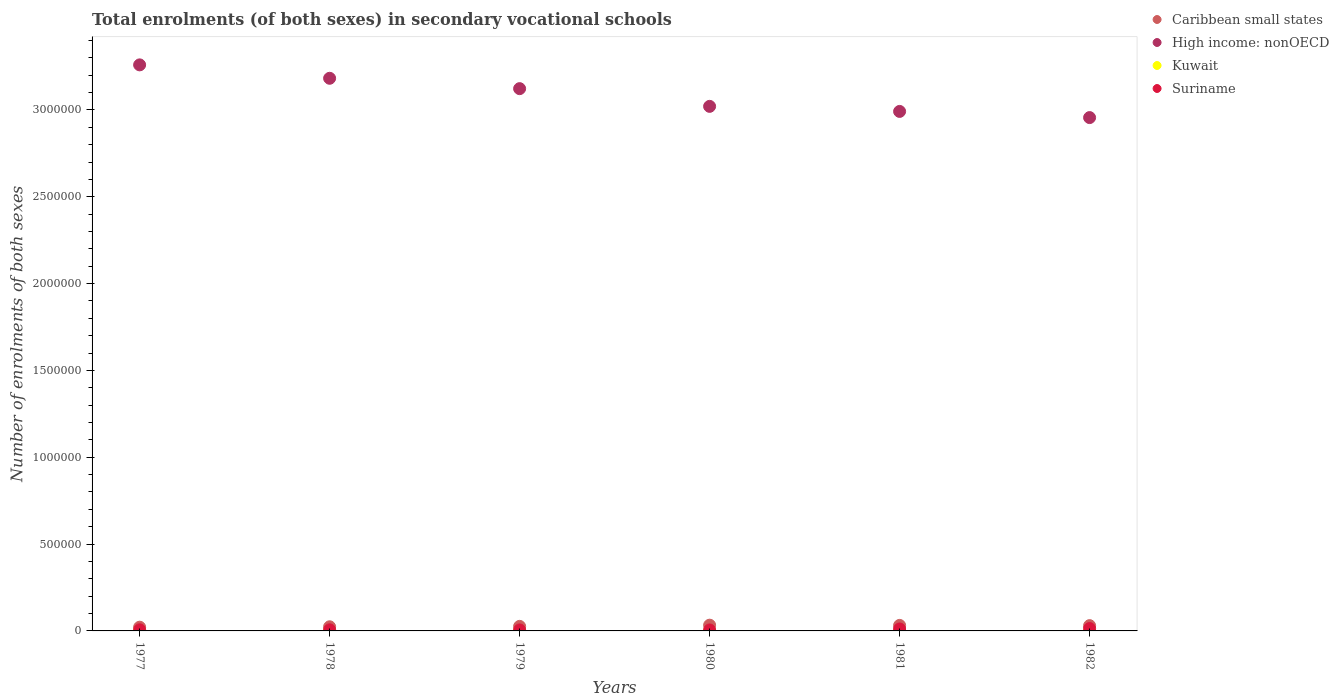How many different coloured dotlines are there?
Your answer should be compact. 4. What is the number of enrolments in secondary schools in Suriname in 1982?
Make the answer very short. 1.37e+04. Across all years, what is the maximum number of enrolments in secondary schools in High income: nonOECD?
Provide a short and direct response. 3.26e+06. Across all years, what is the minimum number of enrolments in secondary schools in Caribbean small states?
Your answer should be very brief. 2.14e+04. In which year was the number of enrolments in secondary schools in Kuwait minimum?
Provide a succinct answer. 1980. What is the total number of enrolments in secondary schools in Suriname in the graph?
Your answer should be compact. 4.91e+04. What is the difference between the number of enrolments in secondary schools in High income: nonOECD in 1979 and that in 1981?
Your answer should be compact. 1.31e+05. What is the difference between the number of enrolments in secondary schools in Kuwait in 1981 and the number of enrolments in secondary schools in Suriname in 1982?
Give a very brief answer. -1.33e+04. What is the average number of enrolments in secondary schools in Suriname per year?
Offer a very short reply. 8178. In the year 1978, what is the difference between the number of enrolments in secondary schools in Caribbean small states and number of enrolments in secondary schools in Kuwait?
Offer a terse response. 2.29e+04. In how many years, is the number of enrolments in secondary schools in Kuwait greater than 3300000?
Ensure brevity in your answer.  0. What is the ratio of the number of enrolments in secondary schools in Caribbean small states in 1980 to that in 1981?
Provide a succinct answer. 1.04. What is the difference between the highest and the second highest number of enrolments in secondary schools in High income: nonOECD?
Provide a succinct answer. 7.72e+04. What is the difference between the highest and the lowest number of enrolments in secondary schools in Suriname?
Make the answer very short. 8151. In how many years, is the number of enrolments in secondary schools in High income: nonOECD greater than the average number of enrolments in secondary schools in High income: nonOECD taken over all years?
Ensure brevity in your answer.  3. Is it the case that in every year, the sum of the number of enrolments in secondary schools in Suriname and number of enrolments in secondary schools in Kuwait  is greater than the sum of number of enrolments in secondary schools in High income: nonOECD and number of enrolments in secondary schools in Caribbean small states?
Give a very brief answer. Yes. Is it the case that in every year, the sum of the number of enrolments in secondary schools in Kuwait and number of enrolments in secondary schools in Caribbean small states  is greater than the number of enrolments in secondary schools in High income: nonOECD?
Offer a terse response. No. Is the number of enrolments in secondary schools in Caribbean small states strictly greater than the number of enrolments in secondary schools in Kuwait over the years?
Your response must be concise. Yes. How many years are there in the graph?
Make the answer very short. 6. What is the difference between two consecutive major ticks on the Y-axis?
Provide a succinct answer. 5.00e+05. Are the values on the major ticks of Y-axis written in scientific E-notation?
Offer a terse response. No. Does the graph contain grids?
Your answer should be compact. No. What is the title of the graph?
Your answer should be very brief. Total enrolments (of both sexes) in secondary vocational schools. What is the label or title of the Y-axis?
Make the answer very short. Number of enrolments of both sexes. What is the Number of enrolments of both sexes in Caribbean small states in 1977?
Offer a terse response. 2.14e+04. What is the Number of enrolments of both sexes of High income: nonOECD in 1977?
Your response must be concise. 3.26e+06. What is the Number of enrolments of both sexes of Kuwait in 1977?
Make the answer very short. 1184. What is the Number of enrolments of both sexes in Suriname in 1977?
Keep it short and to the point. 6375. What is the Number of enrolments of both sexes of Caribbean small states in 1978?
Make the answer very short. 2.38e+04. What is the Number of enrolments of both sexes in High income: nonOECD in 1978?
Your answer should be compact. 3.18e+06. What is the Number of enrolments of both sexes of Kuwait in 1978?
Offer a very short reply. 871. What is the Number of enrolments of both sexes in Suriname in 1978?
Offer a very short reply. 6346. What is the Number of enrolments of both sexes of Caribbean small states in 1979?
Ensure brevity in your answer.  2.62e+04. What is the Number of enrolments of both sexes of High income: nonOECD in 1979?
Your response must be concise. 3.12e+06. What is the Number of enrolments of both sexes in Kuwait in 1979?
Ensure brevity in your answer.  705. What is the Number of enrolments of both sexes of Suriname in 1979?
Give a very brief answer. 5736. What is the Number of enrolments of both sexes of Caribbean small states in 1980?
Keep it short and to the point. 3.31e+04. What is the Number of enrolments of both sexes in High income: nonOECD in 1980?
Your answer should be compact. 3.02e+06. What is the Number of enrolments of both sexes of Kuwait in 1980?
Provide a succinct answer. 403. What is the Number of enrolments of both sexes in Suriname in 1980?
Provide a succinct answer. 5590. What is the Number of enrolments of both sexes in Caribbean small states in 1981?
Offer a terse response. 3.18e+04. What is the Number of enrolments of both sexes in High income: nonOECD in 1981?
Ensure brevity in your answer.  2.99e+06. What is the Number of enrolments of both sexes of Kuwait in 1981?
Give a very brief answer. 421. What is the Number of enrolments of both sexes of Suriname in 1981?
Your answer should be very brief. 1.13e+04. What is the Number of enrolments of both sexes in Caribbean small states in 1982?
Your answer should be compact. 3.04e+04. What is the Number of enrolments of both sexes of High income: nonOECD in 1982?
Provide a succinct answer. 2.96e+06. What is the Number of enrolments of both sexes in Kuwait in 1982?
Offer a very short reply. 672. What is the Number of enrolments of both sexes of Suriname in 1982?
Ensure brevity in your answer.  1.37e+04. Across all years, what is the maximum Number of enrolments of both sexes in Caribbean small states?
Keep it short and to the point. 3.31e+04. Across all years, what is the maximum Number of enrolments of both sexes in High income: nonOECD?
Your answer should be very brief. 3.26e+06. Across all years, what is the maximum Number of enrolments of both sexes of Kuwait?
Make the answer very short. 1184. Across all years, what is the maximum Number of enrolments of both sexes of Suriname?
Offer a very short reply. 1.37e+04. Across all years, what is the minimum Number of enrolments of both sexes of Caribbean small states?
Provide a succinct answer. 2.14e+04. Across all years, what is the minimum Number of enrolments of both sexes of High income: nonOECD?
Ensure brevity in your answer.  2.96e+06. Across all years, what is the minimum Number of enrolments of both sexes of Kuwait?
Ensure brevity in your answer.  403. Across all years, what is the minimum Number of enrolments of both sexes of Suriname?
Provide a short and direct response. 5590. What is the total Number of enrolments of both sexes in Caribbean small states in the graph?
Your response must be concise. 1.67e+05. What is the total Number of enrolments of both sexes of High income: nonOECD in the graph?
Keep it short and to the point. 1.85e+07. What is the total Number of enrolments of both sexes of Kuwait in the graph?
Keep it short and to the point. 4256. What is the total Number of enrolments of both sexes in Suriname in the graph?
Your answer should be compact. 4.91e+04. What is the difference between the Number of enrolments of both sexes in Caribbean small states in 1977 and that in 1978?
Make the answer very short. -2360.25. What is the difference between the Number of enrolments of both sexes of High income: nonOECD in 1977 and that in 1978?
Your answer should be compact. 7.72e+04. What is the difference between the Number of enrolments of both sexes in Kuwait in 1977 and that in 1978?
Your response must be concise. 313. What is the difference between the Number of enrolments of both sexes of Caribbean small states in 1977 and that in 1979?
Provide a short and direct response. -4742. What is the difference between the Number of enrolments of both sexes in High income: nonOECD in 1977 and that in 1979?
Your answer should be very brief. 1.37e+05. What is the difference between the Number of enrolments of both sexes in Kuwait in 1977 and that in 1979?
Keep it short and to the point. 479. What is the difference between the Number of enrolments of both sexes in Suriname in 1977 and that in 1979?
Offer a very short reply. 639. What is the difference between the Number of enrolments of both sexes in Caribbean small states in 1977 and that in 1980?
Provide a short and direct response. -1.17e+04. What is the difference between the Number of enrolments of both sexes in High income: nonOECD in 1977 and that in 1980?
Your response must be concise. 2.39e+05. What is the difference between the Number of enrolments of both sexes in Kuwait in 1977 and that in 1980?
Offer a terse response. 781. What is the difference between the Number of enrolments of both sexes in Suriname in 1977 and that in 1980?
Keep it short and to the point. 785. What is the difference between the Number of enrolments of both sexes in Caribbean small states in 1977 and that in 1981?
Ensure brevity in your answer.  -1.03e+04. What is the difference between the Number of enrolments of both sexes in High income: nonOECD in 1977 and that in 1981?
Your answer should be compact. 2.68e+05. What is the difference between the Number of enrolments of both sexes in Kuwait in 1977 and that in 1981?
Give a very brief answer. 763. What is the difference between the Number of enrolments of both sexes in Suriname in 1977 and that in 1981?
Offer a terse response. -4905. What is the difference between the Number of enrolments of both sexes of Caribbean small states in 1977 and that in 1982?
Offer a terse response. -8942.43. What is the difference between the Number of enrolments of both sexes in High income: nonOECD in 1977 and that in 1982?
Offer a very short reply. 3.04e+05. What is the difference between the Number of enrolments of both sexes of Kuwait in 1977 and that in 1982?
Your response must be concise. 512. What is the difference between the Number of enrolments of both sexes in Suriname in 1977 and that in 1982?
Your answer should be very brief. -7366. What is the difference between the Number of enrolments of both sexes in Caribbean small states in 1978 and that in 1979?
Provide a succinct answer. -2381.75. What is the difference between the Number of enrolments of both sexes of High income: nonOECD in 1978 and that in 1979?
Offer a very short reply. 5.97e+04. What is the difference between the Number of enrolments of both sexes of Kuwait in 1978 and that in 1979?
Offer a terse response. 166. What is the difference between the Number of enrolments of both sexes in Suriname in 1978 and that in 1979?
Your response must be concise. 610. What is the difference between the Number of enrolments of both sexes of Caribbean small states in 1978 and that in 1980?
Keep it short and to the point. -9299.25. What is the difference between the Number of enrolments of both sexes of High income: nonOECD in 1978 and that in 1980?
Offer a terse response. 1.62e+05. What is the difference between the Number of enrolments of both sexes in Kuwait in 1978 and that in 1980?
Offer a terse response. 468. What is the difference between the Number of enrolments of both sexes in Suriname in 1978 and that in 1980?
Your response must be concise. 756. What is the difference between the Number of enrolments of both sexes in Caribbean small states in 1978 and that in 1981?
Offer a terse response. -7966.27. What is the difference between the Number of enrolments of both sexes of High income: nonOECD in 1978 and that in 1981?
Make the answer very short. 1.91e+05. What is the difference between the Number of enrolments of both sexes in Kuwait in 1978 and that in 1981?
Provide a short and direct response. 450. What is the difference between the Number of enrolments of both sexes in Suriname in 1978 and that in 1981?
Make the answer very short. -4934. What is the difference between the Number of enrolments of both sexes in Caribbean small states in 1978 and that in 1982?
Your answer should be very brief. -6582.18. What is the difference between the Number of enrolments of both sexes of High income: nonOECD in 1978 and that in 1982?
Offer a very short reply. 2.26e+05. What is the difference between the Number of enrolments of both sexes of Kuwait in 1978 and that in 1982?
Provide a succinct answer. 199. What is the difference between the Number of enrolments of both sexes in Suriname in 1978 and that in 1982?
Keep it short and to the point. -7395. What is the difference between the Number of enrolments of both sexes of Caribbean small states in 1979 and that in 1980?
Your response must be concise. -6917.51. What is the difference between the Number of enrolments of both sexes of High income: nonOECD in 1979 and that in 1980?
Your answer should be compact. 1.02e+05. What is the difference between the Number of enrolments of both sexes in Kuwait in 1979 and that in 1980?
Offer a terse response. 302. What is the difference between the Number of enrolments of both sexes of Suriname in 1979 and that in 1980?
Provide a short and direct response. 146. What is the difference between the Number of enrolments of both sexes of Caribbean small states in 1979 and that in 1981?
Provide a succinct answer. -5584.52. What is the difference between the Number of enrolments of both sexes in High income: nonOECD in 1979 and that in 1981?
Make the answer very short. 1.31e+05. What is the difference between the Number of enrolments of both sexes in Kuwait in 1979 and that in 1981?
Give a very brief answer. 284. What is the difference between the Number of enrolments of both sexes in Suriname in 1979 and that in 1981?
Ensure brevity in your answer.  -5544. What is the difference between the Number of enrolments of both sexes of Caribbean small states in 1979 and that in 1982?
Your answer should be compact. -4200.43. What is the difference between the Number of enrolments of both sexes of High income: nonOECD in 1979 and that in 1982?
Keep it short and to the point. 1.67e+05. What is the difference between the Number of enrolments of both sexes of Suriname in 1979 and that in 1982?
Offer a terse response. -8005. What is the difference between the Number of enrolments of both sexes of Caribbean small states in 1980 and that in 1981?
Your answer should be very brief. 1332.99. What is the difference between the Number of enrolments of both sexes in High income: nonOECD in 1980 and that in 1981?
Provide a succinct answer. 2.91e+04. What is the difference between the Number of enrolments of both sexes in Kuwait in 1980 and that in 1981?
Your response must be concise. -18. What is the difference between the Number of enrolments of both sexes of Suriname in 1980 and that in 1981?
Provide a succinct answer. -5690. What is the difference between the Number of enrolments of both sexes of Caribbean small states in 1980 and that in 1982?
Keep it short and to the point. 2717.08. What is the difference between the Number of enrolments of both sexes of High income: nonOECD in 1980 and that in 1982?
Provide a short and direct response. 6.47e+04. What is the difference between the Number of enrolments of both sexes in Kuwait in 1980 and that in 1982?
Ensure brevity in your answer.  -269. What is the difference between the Number of enrolments of both sexes of Suriname in 1980 and that in 1982?
Ensure brevity in your answer.  -8151. What is the difference between the Number of enrolments of both sexes of Caribbean small states in 1981 and that in 1982?
Your answer should be very brief. 1384.09. What is the difference between the Number of enrolments of both sexes in High income: nonOECD in 1981 and that in 1982?
Offer a terse response. 3.55e+04. What is the difference between the Number of enrolments of both sexes of Kuwait in 1981 and that in 1982?
Ensure brevity in your answer.  -251. What is the difference between the Number of enrolments of both sexes in Suriname in 1981 and that in 1982?
Make the answer very short. -2461. What is the difference between the Number of enrolments of both sexes of Caribbean small states in 1977 and the Number of enrolments of both sexes of High income: nonOECD in 1978?
Your response must be concise. -3.16e+06. What is the difference between the Number of enrolments of both sexes of Caribbean small states in 1977 and the Number of enrolments of both sexes of Kuwait in 1978?
Ensure brevity in your answer.  2.06e+04. What is the difference between the Number of enrolments of both sexes in Caribbean small states in 1977 and the Number of enrolments of both sexes in Suriname in 1978?
Keep it short and to the point. 1.51e+04. What is the difference between the Number of enrolments of both sexes of High income: nonOECD in 1977 and the Number of enrolments of both sexes of Kuwait in 1978?
Keep it short and to the point. 3.26e+06. What is the difference between the Number of enrolments of both sexes of High income: nonOECD in 1977 and the Number of enrolments of both sexes of Suriname in 1978?
Offer a terse response. 3.25e+06. What is the difference between the Number of enrolments of both sexes in Kuwait in 1977 and the Number of enrolments of both sexes in Suriname in 1978?
Offer a very short reply. -5162. What is the difference between the Number of enrolments of both sexes in Caribbean small states in 1977 and the Number of enrolments of both sexes in High income: nonOECD in 1979?
Your response must be concise. -3.10e+06. What is the difference between the Number of enrolments of both sexes in Caribbean small states in 1977 and the Number of enrolments of both sexes in Kuwait in 1979?
Provide a short and direct response. 2.07e+04. What is the difference between the Number of enrolments of both sexes in Caribbean small states in 1977 and the Number of enrolments of both sexes in Suriname in 1979?
Your answer should be compact. 1.57e+04. What is the difference between the Number of enrolments of both sexes in High income: nonOECD in 1977 and the Number of enrolments of both sexes in Kuwait in 1979?
Your answer should be very brief. 3.26e+06. What is the difference between the Number of enrolments of both sexes in High income: nonOECD in 1977 and the Number of enrolments of both sexes in Suriname in 1979?
Your answer should be very brief. 3.25e+06. What is the difference between the Number of enrolments of both sexes of Kuwait in 1977 and the Number of enrolments of both sexes of Suriname in 1979?
Offer a very short reply. -4552. What is the difference between the Number of enrolments of both sexes in Caribbean small states in 1977 and the Number of enrolments of both sexes in High income: nonOECD in 1980?
Your answer should be very brief. -3.00e+06. What is the difference between the Number of enrolments of both sexes of Caribbean small states in 1977 and the Number of enrolments of both sexes of Kuwait in 1980?
Give a very brief answer. 2.10e+04. What is the difference between the Number of enrolments of both sexes in Caribbean small states in 1977 and the Number of enrolments of both sexes in Suriname in 1980?
Your answer should be compact. 1.59e+04. What is the difference between the Number of enrolments of both sexes of High income: nonOECD in 1977 and the Number of enrolments of both sexes of Kuwait in 1980?
Ensure brevity in your answer.  3.26e+06. What is the difference between the Number of enrolments of both sexes in High income: nonOECD in 1977 and the Number of enrolments of both sexes in Suriname in 1980?
Offer a terse response. 3.25e+06. What is the difference between the Number of enrolments of both sexes in Kuwait in 1977 and the Number of enrolments of both sexes in Suriname in 1980?
Your answer should be compact. -4406. What is the difference between the Number of enrolments of both sexes in Caribbean small states in 1977 and the Number of enrolments of both sexes in High income: nonOECD in 1981?
Offer a very short reply. -2.97e+06. What is the difference between the Number of enrolments of both sexes of Caribbean small states in 1977 and the Number of enrolments of both sexes of Kuwait in 1981?
Offer a very short reply. 2.10e+04. What is the difference between the Number of enrolments of both sexes in Caribbean small states in 1977 and the Number of enrolments of both sexes in Suriname in 1981?
Make the answer very short. 1.02e+04. What is the difference between the Number of enrolments of both sexes of High income: nonOECD in 1977 and the Number of enrolments of both sexes of Kuwait in 1981?
Offer a very short reply. 3.26e+06. What is the difference between the Number of enrolments of both sexes in High income: nonOECD in 1977 and the Number of enrolments of both sexes in Suriname in 1981?
Give a very brief answer. 3.25e+06. What is the difference between the Number of enrolments of both sexes of Kuwait in 1977 and the Number of enrolments of both sexes of Suriname in 1981?
Make the answer very short. -1.01e+04. What is the difference between the Number of enrolments of both sexes in Caribbean small states in 1977 and the Number of enrolments of both sexes in High income: nonOECD in 1982?
Give a very brief answer. -2.93e+06. What is the difference between the Number of enrolments of both sexes in Caribbean small states in 1977 and the Number of enrolments of both sexes in Kuwait in 1982?
Offer a very short reply. 2.08e+04. What is the difference between the Number of enrolments of both sexes of Caribbean small states in 1977 and the Number of enrolments of both sexes of Suriname in 1982?
Keep it short and to the point. 7703.19. What is the difference between the Number of enrolments of both sexes in High income: nonOECD in 1977 and the Number of enrolments of both sexes in Kuwait in 1982?
Give a very brief answer. 3.26e+06. What is the difference between the Number of enrolments of both sexes in High income: nonOECD in 1977 and the Number of enrolments of both sexes in Suriname in 1982?
Ensure brevity in your answer.  3.25e+06. What is the difference between the Number of enrolments of both sexes in Kuwait in 1977 and the Number of enrolments of both sexes in Suriname in 1982?
Offer a terse response. -1.26e+04. What is the difference between the Number of enrolments of both sexes of Caribbean small states in 1978 and the Number of enrolments of both sexes of High income: nonOECD in 1979?
Give a very brief answer. -3.10e+06. What is the difference between the Number of enrolments of both sexes of Caribbean small states in 1978 and the Number of enrolments of both sexes of Kuwait in 1979?
Offer a terse response. 2.31e+04. What is the difference between the Number of enrolments of both sexes of Caribbean small states in 1978 and the Number of enrolments of both sexes of Suriname in 1979?
Keep it short and to the point. 1.81e+04. What is the difference between the Number of enrolments of both sexes of High income: nonOECD in 1978 and the Number of enrolments of both sexes of Kuwait in 1979?
Offer a very short reply. 3.18e+06. What is the difference between the Number of enrolments of both sexes in High income: nonOECD in 1978 and the Number of enrolments of both sexes in Suriname in 1979?
Give a very brief answer. 3.18e+06. What is the difference between the Number of enrolments of both sexes of Kuwait in 1978 and the Number of enrolments of both sexes of Suriname in 1979?
Keep it short and to the point. -4865. What is the difference between the Number of enrolments of both sexes of Caribbean small states in 1978 and the Number of enrolments of both sexes of High income: nonOECD in 1980?
Give a very brief answer. -3.00e+06. What is the difference between the Number of enrolments of both sexes in Caribbean small states in 1978 and the Number of enrolments of both sexes in Kuwait in 1980?
Make the answer very short. 2.34e+04. What is the difference between the Number of enrolments of both sexes in Caribbean small states in 1978 and the Number of enrolments of both sexes in Suriname in 1980?
Make the answer very short. 1.82e+04. What is the difference between the Number of enrolments of both sexes in High income: nonOECD in 1978 and the Number of enrolments of both sexes in Kuwait in 1980?
Provide a succinct answer. 3.18e+06. What is the difference between the Number of enrolments of both sexes of High income: nonOECD in 1978 and the Number of enrolments of both sexes of Suriname in 1980?
Make the answer very short. 3.18e+06. What is the difference between the Number of enrolments of both sexes in Kuwait in 1978 and the Number of enrolments of both sexes in Suriname in 1980?
Offer a terse response. -4719. What is the difference between the Number of enrolments of both sexes in Caribbean small states in 1978 and the Number of enrolments of both sexes in High income: nonOECD in 1981?
Keep it short and to the point. -2.97e+06. What is the difference between the Number of enrolments of both sexes of Caribbean small states in 1978 and the Number of enrolments of both sexes of Kuwait in 1981?
Make the answer very short. 2.34e+04. What is the difference between the Number of enrolments of both sexes of Caribbean small states in 1978 and the Number of enrolments of both sexes of Suriname in 1981?
Make the answer very short. 1.25e+04. What is the difference between the Number of enrolments of both sexes in High income: nonOECD in 1978 and the Number of enrolments of both sexes in Kuwait in 1981?
Provide a short and direct response. 3.18e+06. What is the difference between the Number of enrolments of both sexes in High income: nonOECD in 1978 and the Number of enrolments of both sexes in Suriname in 1981?
Offer a very short reply. 3.17e+06. What is the difference between the Number of enrolments of both sexes of Kuwait in 1978 and the Number of enrolments of both sexes of Suriname in 1981?
Make the answer very short. -1.04e+04. What is the difference between the Number of enrolments of both sexes in Caribbean small states in 1978 and the Number of enrolments of both sexes in High income: nonOECD in 1982?
Keep it short and to the point. -2.93e+06. What is the difference between the Number of enrolments of both sexes in Caribbean small states in 1978 and the Number of enrolments of both sexes in Kuwait in 1982?
Your response must be concise. 2.31e+04. What is the difference between the Number of enrolments of both sexes of Caribbean small states in 1978 and the Number of enrolments of both sexes of Suriname in 1982?
Your answer should be very brief. 1.01e+04. What is the difference between the Number of enrolments of both sexes of High income: nonOECD in 1978 and the Number of enrolments of both sexes of Kuwait in 1982?
Your answer should be compact. 3.18e+06. What is the difference between the Number of enrolments of both sexes of High income: nonOECD in 1978 and the Number of enrolments of both sexes of Suriname in 1982?
Your response must be concise. 3.17e+06. What is the difference between the Number of enrolments of both sexes of Kuwait in 1978 and the Number of enrolments of both sexes of Suriname in 1982?
Keep it short and to the point. -1.29e+04. What is the difference between the Number of enrolments of both sexes of Caribbean small states in 1979 and the Number of enrolments of both sexes of High income: nonOECD in 1980?
Your answer should be compact. -2.99e+06. What is the difference between the Number of enrolments of both sexes of Caribbean small states in 1979 and the Number of enrolments of both sexes of Kuwait in 1980?
Provide a succinct answer. 2.58e+04. What is the difference between the Number of enrolments of both sexes in Caribbean small states in 1979 and the Number of enrolments of both sexes in Suriname in 1980?
Provide a succinct answer. 2.06e+04. What is the difference between the Number of enrolments of both sexes of High income: nonOECD in 1979 and the Number of enrolments of both sexes of Kuwait in 1980?
Offer a very short reply. 3.12e+06. What is the difference between the Number of enrolments of both sexes in High income: nonOECD in 1979 and the Number of enrolments of both sexes in Suriname in 1980?
Offer a terse response. 3.12e+06. What is the difference between the Number of enrolments of both sexes of Kuwait in 1979 and the Number of enrolments of both sexes of Suriname in 1980?
Your answer should be compact. -4885. What is the difference between the Number of enrolments of both sexes of Caribbean small states in 1979 and the Number of enrolments of both sexes of High income: nonOECD in 1981?
Ensure brevity in your answer.  -2.97e+06. What is the difference between the Number of enrolments of both sexes of Caribbean small states in 1979 and the Number of enrolments of both sexes of Kuwait in 1981?
Give a very brief answer. 2.58e+04. What is the difference between the Number of enrolments of both sexes of Caribbean small states in 1979 and the Number of enrolments of both sexes of Suriname in 1981?
Make the answer very short. 1.49e+04. What is the difference between the Number of enrolments of both sexes in High income: nonOECD in 1979 and the Number of enrolments of both sexes in Kuwait in 1981?
Give a very brief answer. 3.12e+06. What is the difference between the Number of enrolments of both sexes in High income: nonOECD in 1979 and the Number of enrolments of both sexes in Suriname in 1981?
Your response must be concise. 3.11e+06. What is the difference between the Number of enrolments of both sexes in Kuwait in 1979 and the Number of enrolments of both sexes in Suriname in 1981?
Ensure brevity in your answer.  -1.06e+04. What is the difference between the Number of enrolments of both sexes in Caribbean small states in 1979 and the Number of enrolments of both sexes in High income: nonOECD in 1982?
Your response must be concise. -2.93e+06. What is the difference between the Number of enrolments of both sexes in Caribbean small states in 1979 and the Number of enrolments of both sexes in Kuwait in 1982?
Offer a terse response. 2.55e+04. What is the difference between the Number of enrolments of both sexes of Caribbean small states in 1979 and the Number of enrolments of both sexes of Suriname in 1982?
Offer a very short reply. 1.24e+04. What is the difference between the Number of enrolments of both sexes in High income: nonOECD in 1979 and the Number of enrolments of both sexes in Kuwait in 1982?
Keep it short and to the point. 3.12e+06. What is the difference between the Number of enrolments of both sexes of High income: nonOECD in 1979 and the Number of enrolments of both sexes of Suriname in 1982?
Offer a very short reply. 3.11e+06. What is the difference between the Number of enrolments of both sexes of Kuwait in 1979 and the Number of enrolments of both sexes of Suriname in 1982?
Offer a terse response. -1.30e+04. What is the difference between the Number of enrolments of both sexes in Caribbean small states in 1980 and the Number of enrolments of both sexes in High income: nonOECD in 1981?
Provide a short and direct response. -2.96e+06. What is the difference between the Number of enrolments of both sexes in Caribbean small states in 1980 and the Number of enrolments of both sexes in Kuwait in 1981?
Give a very brief answer. 3.27e+04. What is the difference between the Number of enrolments of both sexes of Caribbean small states in 1980 and the Number of enrolments of both sexes of Suriname in 1981?
Provide a short and direct response. 2.18e+04. What is the difference between the Number of enrolments of both sexes of High income: nonOECD in 1980 and the Number of enrolments of both sexes of Kuwait in 1981?
Your response must be concise. 3.02e+06. What is the difference between the Number of enrolments of both sexes in High income: nonOECD in 1980 and the Number of enrolments of both sexes in Suriname in 1981?
Your answer should be compact. 3.01e+06. What is the difference between the Number of enrolments of both sexes of Kuwait in 1980 and the Number of enrolments of both sexes of Suriname in 1981?
Provide a succinct answer. -1.09e+04. What is the difference between the Number of enrolments of both sexes in Caribbean small states in 1980 and the Number of enrolments of both sexes in High income: nonOECD in 1982?
Offer a terse response. -2.92e+06. What is the difference between the Number of enrolments of both sexes in Caribbean small states in 1980 and the Number of enrolments of both sexes in Kuwait in 1982?
Your answer should be compact. 3.24e+04. What is the difference between the Number of enrolments of both sexes in Caribbean small states in 1980 and the Number of enrolments of both sexes in Suriname in 1982?
Provide a short and direct response. 1.94e+04. What is the difference between the Number of enrolments of both sexes in High income: nonOECD in 1980 and the Number of enrolments of both sexes in Kuwait in 1982?
Your response must be concise. 3.02e+06. What is the difference between the Number of enrolments of both sexes in High income: nonOECD in 1980 and the Number of enrolments of both sexes in Suriname in 1982?
Give a very brief answer. 3.01e+06. What is the difference between the Number of enrolments of both sexes in Kuwait in 1980 and the Number of enrolments of both sexes in Suriname in 1982?
Keep it short and to the point. -1.33e+04. What is the difference between the Number of enrolments of both sexes in Caribbean small states in 1981 and the Number of enrolments of both sexes in High income: nonOECD in 1982?
Your answer should be compact. -2.92e+06. What is the difference between the Number of enrolments of both sexes of Caribbean small states in 1981 and the Number of enrolments of both sexes of Kuwait in 1982?
Your answer should be compact. 3.11e+04. What is the difference between the Number of enrolments of both sexes in Caribbean small states in 1981 and the Number of enrolments of both sexes in Suriname in 1982?
Give a very brief answer. 1.80e+04. What is the difference between the Number of enrolments of both sexes of High income: nonOECD in 1981 and the Number of enrolments of both sexes of Kuwait in 1982?
Offer a terse response. 2.99e+06. What is the difference between the Number of enrolments of both sexes of High income: nonOECD in 1981 and the Number of enrolments of both sexes of Suriname in 1982?
Provide a succinct answer. 2.98e+06. What is the difference between the Number of enrolments of both sexes in Kuwait in 1981 and the Number of enrolments of both sexes in Suriname in 1982?
Your answer should be compact. -1.33e+04. What is the average Number of enrolments of both sexes in Caribbean small states per year?
Make the answer very short. 2.78e+04. What is the average Number of enrolments of both sexes in High income: nonOECD per year?
Your answer should be very brief. 3.09e+06. What is the average Number of enrolments of both sexes of Kuwait per year?
Make the answer very short. 709.33. What is the average Number of enrolments of both sexes in Suriname per year?
Provide a succinct answer. 8178. In the year 1977, what is the difference between the Number of enrolments of both sexes of Caribbean small states and Number of enrolments of both sexes of High income: nonOECD?
Your answer should be compact. -3.24e+06. In the year 1977, what is the difference between the Number of enrolments of both sexes of Caribbean small states and Number of enrolments of both sexes of Kuwait?
Your answer should be compact. 2.03e+04. In the year 1977, what is the difference between the Number of enrolments of both sexes of Caribbean small states and Number of enrolments of both sexes of Suriname?
Your answer should be very brief. 1.51e+04. In the year 1977, what is the difference between the Number of enrolments of both sexes of High income: nonOECD and Number of enrolments of both sexes of Kuwait?
Offer a very short reply. 3.26e+06. In the year 1977, what is the difference between the Number of enrolments of both sexes in High income: nonOECD and Number of enrolments of both sexes in Suriname?
Make the answer very short. 3.25e+06. In the year 1977, what is the difference between the Number of enrolments of both sexes of Kuwait and Number of enrolments of both sexes of Suriname?
Your answer should be compact. -5191. In the year 1978, what is the difference between the Number of enrolments of both sexes in Caribbean small states and Number of enrolments of both sexes in High income: nonOECD?
Keep it short and to the point. -3.16e+06. In the year 1978, what is the difference between the Number of enrolments of both sexes of Caribbean small states and Number of enrolments of both sexes of Kuwait?
Provide a short and direct response. 2.29e+04. In the year 1978, what is the difference between the Number of enrolments of both sexes in Caribbean small states and Number of enrolments of both sexes in Suriname?
Offer a terse response. 1.75e+04. In the year 1978, what is the difference between the Number of enrolments of both sexes in High income: nonOECD and Number of enrolments of both sexes in Kuwait?
Ensure brevity in your answer.  3.18e+06. In the year 1978, what is the difference between the Number of enrolments of both sexes of High income: nonOECD and Number of enrolments of both sexes of Suriname?
Provide a succinct answer. 3.18e+06. In the year 1978, what is the difference between the Number of enrolments of both sexes in Kuwait and Number of enrolments of both sexes in Suriname?
Your response must be concise. -5475. In the year 1979, what is the difference between the Number of enrolments of both sexes in Caribbean small states and Number of enrolments of both sexes in High income: nonOECD?
Keep it short and to the point. -3.10e+06. In the year 1979, what is the difference between the Number of enrolments of both sexes in Caribbean small states and Number of enrolments of both sexes in Kuwait?
Keep it short and to the point. 2.55e+04. In the year 1979, what is the difference between the Number of enrolments of both sexes in Caribbean small states and Number of enrolments of both sexes in Suriname?
Keep it short and to the point. 2.05e+04. In the year 1979, what is the difference between the Number of enrolments of both sexes in High income: nonOECD and Number of enrolments of both sexes in Kuwait?
Your answer should be compact. 3.12e+06. In the year 1979, what is the difference between the Number of enrolments of both sexes in High income: nonOECD and Number of enrolments of both sexes in Suriname?
Your answer should be compact. 3.12e+06. In the year 1979, what is the difference between the Number of enrolments of both sexes of Kuwait and Number of enrolments of both sexes of Suriname?
Provide a succinct answer. -5031. In the year 1980, what is the difference between the Number of enrolments of both sexes of Caribbean small states and Number of enrolments of both sexes of High income: nonOECD?
Offer a terse response. -2.99e+06. In the year 1980, what is the difference between the Number of enrolments of both sexes in Caribbean small states and Number of enrolments of both sexes in Kuwait?
Your answer should be very brief. 3.27e+04. In the year 1980, what is the difference between the Number of enrolments of both sexes in Caribbean small states and Number of enrolments of both sexes in Suriname?
Offer a very short reply. 2.75e+04. In the year 1980, what is the difference between the Number of enrolments of both sexes in High income: nonOECD and Number of enrolments of both sexes in Kuwait?
Your response must be concise. 3.02e+06. In the year 1980, what is the difference between the Number of enrolments of both sexes of High income: nonOECD and Number of enrolments of both sexes of Suriname?
Ensure brevity in your answer.  3.02e+06. In the year 1980, what is the difference between the Number of enrolments of both sexes of Kuwait and Number of enrolments of both sexes of Suriname?
Your answer should be very brief. -5187. In the year 1981, what is the difference between the Number of enrolments of both sexes of Caribbean small states and Number of enrolments of both sexes of High income: nonOECD?
Keep it short and to the point. -2.96e+06. In the year 1981, what is the difference between the Number of enrolments of both sexes of Caribbean small states and Number of enrolments of both sexes of Kuwait?
Ensure brevity in your answer.  3.13e+04. In the year 1981, what is the difference between the Number of enrolments of both sexes of Caribbean small states and Number of enrolments of both sexes of Suriname?
Offer a terse response. 2.05e+04. In the year 1981, what is the difference between the Number of enrolments of both sexes of High income: nonOECD and Number of enrolments of both sexes of Kuwait?
Ensure brevity in your answer.  2.99e+06. In the year 1981, what is the difference between the Number of enrolments of both sexes in High income: nonOECD and Number of enrolments of both sexes in Suriname?
Make the answer very short. 2.98e+06. In the year 1981, what is the difference between the Number of enrolments of both sexes in Kuwait and Number of enrolments of both sexes in Suriname?
Your answer should be very brief. -1.09e+04. In the year 1982, what is the difference between the Number of enrolments of both sexes in Caribbean small states and Number of enrolments of both sexes in High income: nonOECD?
Provide a short and direct response. -2.93e+06. In the year 1982, what is the difference between the Number of enrolments of both sexes in Caribbean small states and Number of enrolments of both sexes in Kuwait?
Your response must be concise. 2.97e+04. In the year 1982, what is the difference between the Number of enrolments of both sexes of Caribbean small states and Number of enrolments of both sexes of Suriname?
Your answer should be very brief. 1.66e+04. In the year 1982, what is the difference between the Number of enrolments of both sexes in High income: nonOECD and Number of enrolments of both sexes in Kuwait?
Offer a very short reply. 2.96e+06. In the year 1982, what is the difference between the Number of enrolments of both sexes of High income: nonOECD and Number of enrolments of both sexes of Suriname?
Ensure brevity in your answer.  2.94e+06. In the year 1982, what is the difference between the Number of enrolments of both sexes of Kuwait and Number of enrolments of both sexes of Suriname?
Give a very brief answer. -1.31e+04. What is the ratio of the Number of enrolments of both sexes of Caribbean small states in 1977 to that in 1978?
Make the answer very short. 0.9. What is the ratio of the Number of enrolments of both sexes in High income: nonOECD in 1977 to that in 1978?
Ensure brevity in your answer.  1.02. What is the ratio of the Number of enrolments of both sexes of Kuwait in 1977 to that in 1978?
Ensure brevity in your answer.  1.36. What is the ratio of the Number of enrolments of both sexes of Suriname in 1977 to that in 1978?
Offer a very short reply. 1. What is the ratio of the Number of enrolments of both sexes of Caribbean small states in 1977 to that in 1979?
Give a very brief answer. 0.82. What is the ratio of the Number of enrolments of both sexes of High income: nonOECD in 1977 to that in 1979?
Provide a succinct answer. 1.04. What is the ratio of the Number of enrolments of both sexes of Kuwait in 1977 to that in 1979?
Provide a short and direct response. 1.68. What is the ratio of the Number of enrolments of both sexes in Suriname in 1977 to that in 1979?
Your answer should be compact. 1.11. What is the ratio of the Number of enrolments of both sexes of Caribbean small states in 1977 to that in 1980?
Your answer should be very brief. 0.65. What is the ratio of the Number of enrolments of both sexes in High income: nonOECD in 1977 to that in 1980?
Make the answer very short. 1.08. What is the ratio of the Number of enrolments of both sexes of Kuwait in 1977 to that in 1980?
Ensure brevity in your answer.  2.94. What is the ratio of the Number of enrolments of both sexes of Suriname in 1977 to that in 1980?
Give a very brief answer. 1.14. What is the ratio of the Number of enrolments of both sexes in Caribbean small states in 1977 to that in 1981?
Offer a very short reply. 0.68. What is the ratio of the Number of enrolments of both sexes in High income: nonOECD in 1977 to that in 1981?
Offer a terse response. 1.09. What is the ratio of the Number of enrolments of both sexes of Kuwait in 1977 to that in 1981?
Provide a succinct answer. 2.81. What is the ratio of the Number of enrolments of both sexes in Suriname in 1977 to that in 1981?
Your response must be concise. 0.57. What is the ratio of the Number of enrolments of both sexes in Caribbean small states in 1977 to that in 1982?
Your response must be concise. 0.71. What is the ratio of the Number of enrolments of both sexes in High income: nonOECD in 1977 to that in 1982?
Provide a short and direct response. 1.1. What is the ratio of the Number of enrolments of both sexes in Kuwait in 1977 to that in 1982?
Offer a terse response. 1.76. What is the ratio of the Number of enrolments of both sexes in Suriname in 1977 to that in 1982?
Your answer should be very brief. 0.46. What is the ratio of the Number of enrolments of both sexes of Caribbean small states in 1978 to that in 1979?
Keep it short and to the point. 0.91. What is the ratio of the Number of enrolments of both sexes in High income: nonOECD in 1978 to that in 1979?
Keep it short and to the point. 1.02. What is the ratio of the Number of enrolments of both sexes in Kuwait in 1978 to that in 1979?
Provide a short and direct response. 1.24. What is the ratio of the Number of enrolments of both sexes of Suriname in 1978 to that in 1979?
Your answer should be very brief. 1.11. What is the ratio of the Number of enrolments of both sexes of Caribbean small states in 1978 to that in 1980?
Provide a short and direct response. 0.72. What is the ratio of the Number of enrolments of both sexes in High income: nonOECD in 1978 to that in 1980?
Your answer should be very brief. 1.05. What is the ratio of the Number of enrolments of both sexes of Kuwait in 1978 to that in 1980?
Ensure brevity in your answer.  2.16. What is the ratio of the Number of enrolments of both sexes of Suriname in 1978 to that in 1980?
Provide a succinct answer. 1.14. What is the ratio of the Number of enrolments of both sexes in Caribbean small states in 1978 to that in 1981?
Provide a succinct answer. 0.75. What is the ratio of the Number of enrolments of both sexes in High income: nonOECD in 1978 to that in 1981?
Provide a short and direct response. 1.06. What is the ratio of the Number of enrolments of both sexes in Kuwait in 1978 to that in 1981?
Keep it short and to the point. 2.07. What is the ratio of the Number of enrolments of both sexes of Suriname in 1978 to that in 1981?
Your answer should be very brief. 0.56. What is the ratio of the Number of enrolments of both sexes of Caribbean small states in 1978 to that in 1982?
Give a very brief answer. 0.78. What is the ratio of the Number of enrolments of both sexes in High income: nonOECD in 1978 to that in 1982?
Give a very brief answer. 1.08. What is the ratio of the Number of enrolments of both sexes of Kuwait in 1978 to that in 1982?
Your response must be concise. 1.3. What is the ratio of the Number of enrolments of both sexes in Suriname in 1978 to that in 1982?
Provide a short and direct response. 0.46. What is the ratio of the Number of enrolments of both sexes of Caribbean small states in 1979 to that in 1980?
Provide a succinct answer. 0.79. What is the ratio of the Number of enrolments of both sexes of High income: nonOECD in 1979 to that in 1980?
Give a very brief answer. 1.03. What is the ratio of the Number of enrolments of both sexes of Kuwait in 1979 to that in 1980?
Your response must be concise. 1.75. What is the ratio of the Number of enrolments of both sexes in Suriname in 1979 to that in 1980?
Offer a very short reply. 1.03. What is the ratio of the Number of enrolments of both sexes in Caribbean small states in 1979 to that in 1981?
Ensure brevity in your answer.  0.82. What is the ratio of the Number of enrolments of both sexes in High income: nonOECD in 1979 to that in 1981?
Make the answer very short. 1.04. What is the ratio of the Number of enrolments of both sexes in Kuwait in 1979 to that in 1981?
Keep it short and to the point. 1.67. What is the ratio of the Number of enrolments of both sexes of Suriname in 1979 to that in 1981?
Keep it short and to the point. 0.51. What is the ratio of the Number of enrolments of both sexes of Caribbean small states in 1979 to that in 1982?
Your answer should be compact. 0.86. What is the ratio of the Number of enrolments of both sexes in High income: nonOECD in 1979 to that in 1982?
Your answer should be very brief. 1.06. What is the ratio of the Number of enrolments of both sexes of Kuwait in 1979 to that in 1982?
Provide a short and direct response. 1.05. What is the ratio of the Number of enrolments of both sexes of Suriname in 1979 to that in 1982?
Your answer should be very brief. 0.42. What is the ratio of the Number of enrolments of both sexes of Caribbean small states in 1980 to that in 1981?
Ensure brevity in your answer.  1.04. What is the ratio of the Number of enrolments of both sexes of High income: nonOECD in 1980 to that in 1981?
Make the answer very short. 1.01. What is the ratio of the Number of enrolments of both sexes of Kuwait in 1980 to that in 1981?
Keep it short and to the point. 0.96. What is the ratio of the Number of enrolments of both sexes of Suriname in 1980 to that in 1981?
Keep it short and to the point. 0.5. What is the ratio of the Number of enrolments of both sexes of Caribbean small states in 1980 to that in 1982?
Your answer should be very brief. 1.09. What is the ratio of the Number of enrolments of both sexes in High income: nonOECD in 1980 to that in 1982?
Offer a very short reply. 1.02. What is the ratio of the Number of enrolments of both sexes in Kuwait in 1980 to that in 1982?
Give a very brief answer. 0.6. What is the ratio of the Number of enrolments of both sexes of Suriname in 1980 to that in 1982?
Offer a very short reply. 0.41. What is the ratio of the Number of enrolments of both sexes of Caribbean small states in 1981 to that in 1982?
Offer a very short reply. 1.05. What is the ratio of the Number of enrolments of both sexes of Kuwait in 1981 to that in 1982?
Make the answer very short. 0.63. What is the ratio of the Number of enrolments of both sexes of Suriname in 1981 to that in 1982?
Your answer should be very brief. 0.82. What is the difference between the highest and the second highest Number of enrolments of both sexes in Caribbean small states?
Your answer should be very brief. 1332.99. What is the difference between the highest and the second highest Number of enrolments of both sexes of High income: nonOECD?
Ensure brevity in your answer.  7.72e+04. What is the difference between the highest and the second highest Number of enrolments of both sexes of Kuwait?
Your answer should be very brief. 313. What is the difference between the highest and the second highest Number of enrolments of both sexes in Suriname?
Ensure brevity in your answer.  2461. What is the difference between the highest and the lowest Number of enrolments of both sexes of Caribbean small states?
Provide a short and direct response. 1.17e+04. What is the difference between the highest and the lowest Number of enrolments of both sexes of High income: nonOECD?
Your response must be concise. 3.04e+05. What is the difference between the highest and the lowest Number of enrolments of both sexes of Kuwait?
Offer a very short reply. 781. What is the difference between the highest and the lowest Number of enrolments of both sexes in Suriname?
Your answer should be compact. 8151. 